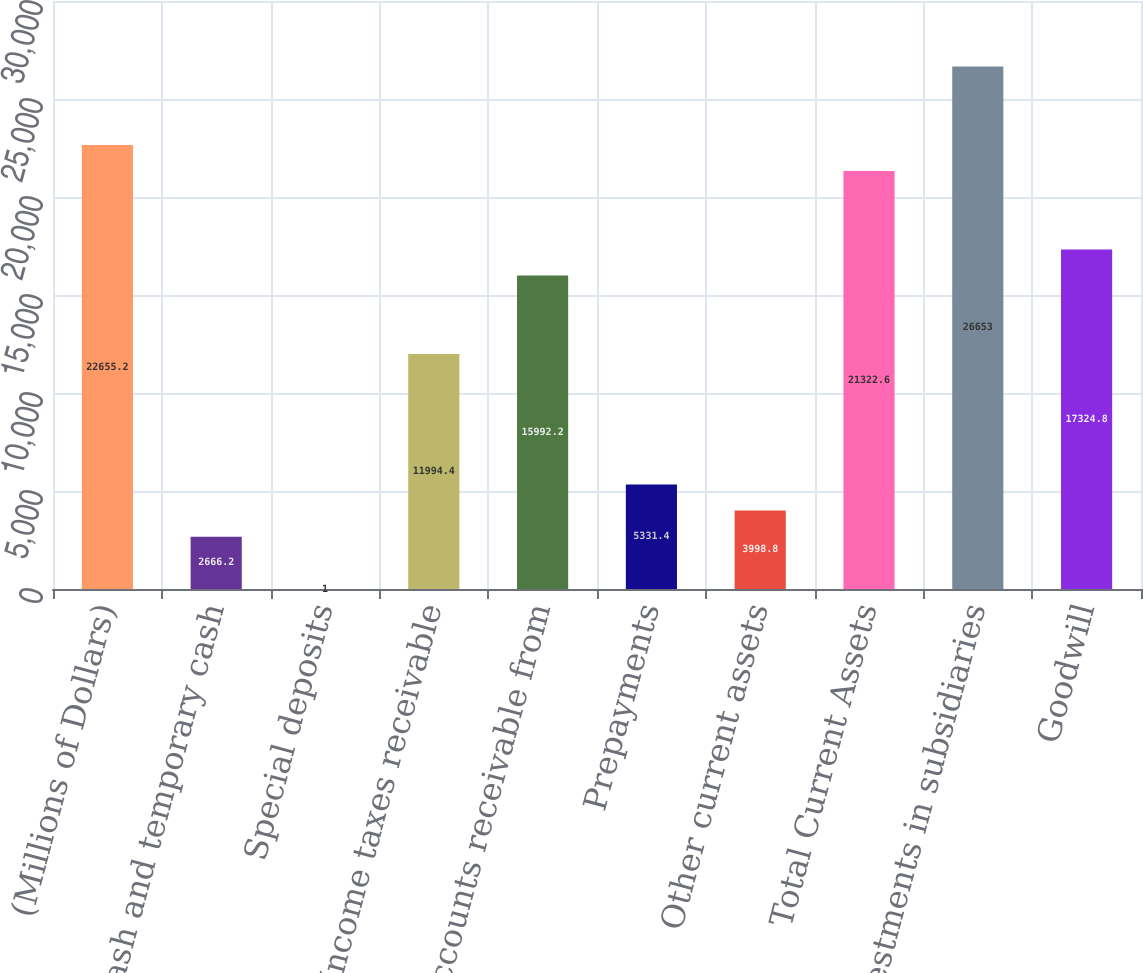Convert chart to OTSL. <chart><loc_0><loc_0><loc_500><loc_500><bar_chart><fcel>(Millions of Dollars)<fcel>Cash and temporary cash<fcel>Special deposits<fcel>Income taxes receivable<fcel>Accounts receivable from<fcel>Prepayments<fcel>Other current assets<fcel>Total Current Assets<fcel>Investments in subsidiaries<fcel>Goodwill<nl><fcel>22655.2<fcel>2666.2<fcel>1<fcel>11994.4<fcel>15992.2<fcel>5331.4<fcel>3998.8<fcel>21322.6<fcel>26653<fcel>17324.8<nl></chart> 